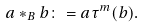Convert formula to latex. <formula><loc_0><loc_0><loc_500><loc_500>a * _ { B } b \colon = a \tau ^ { m } ( b ) .</formula> 